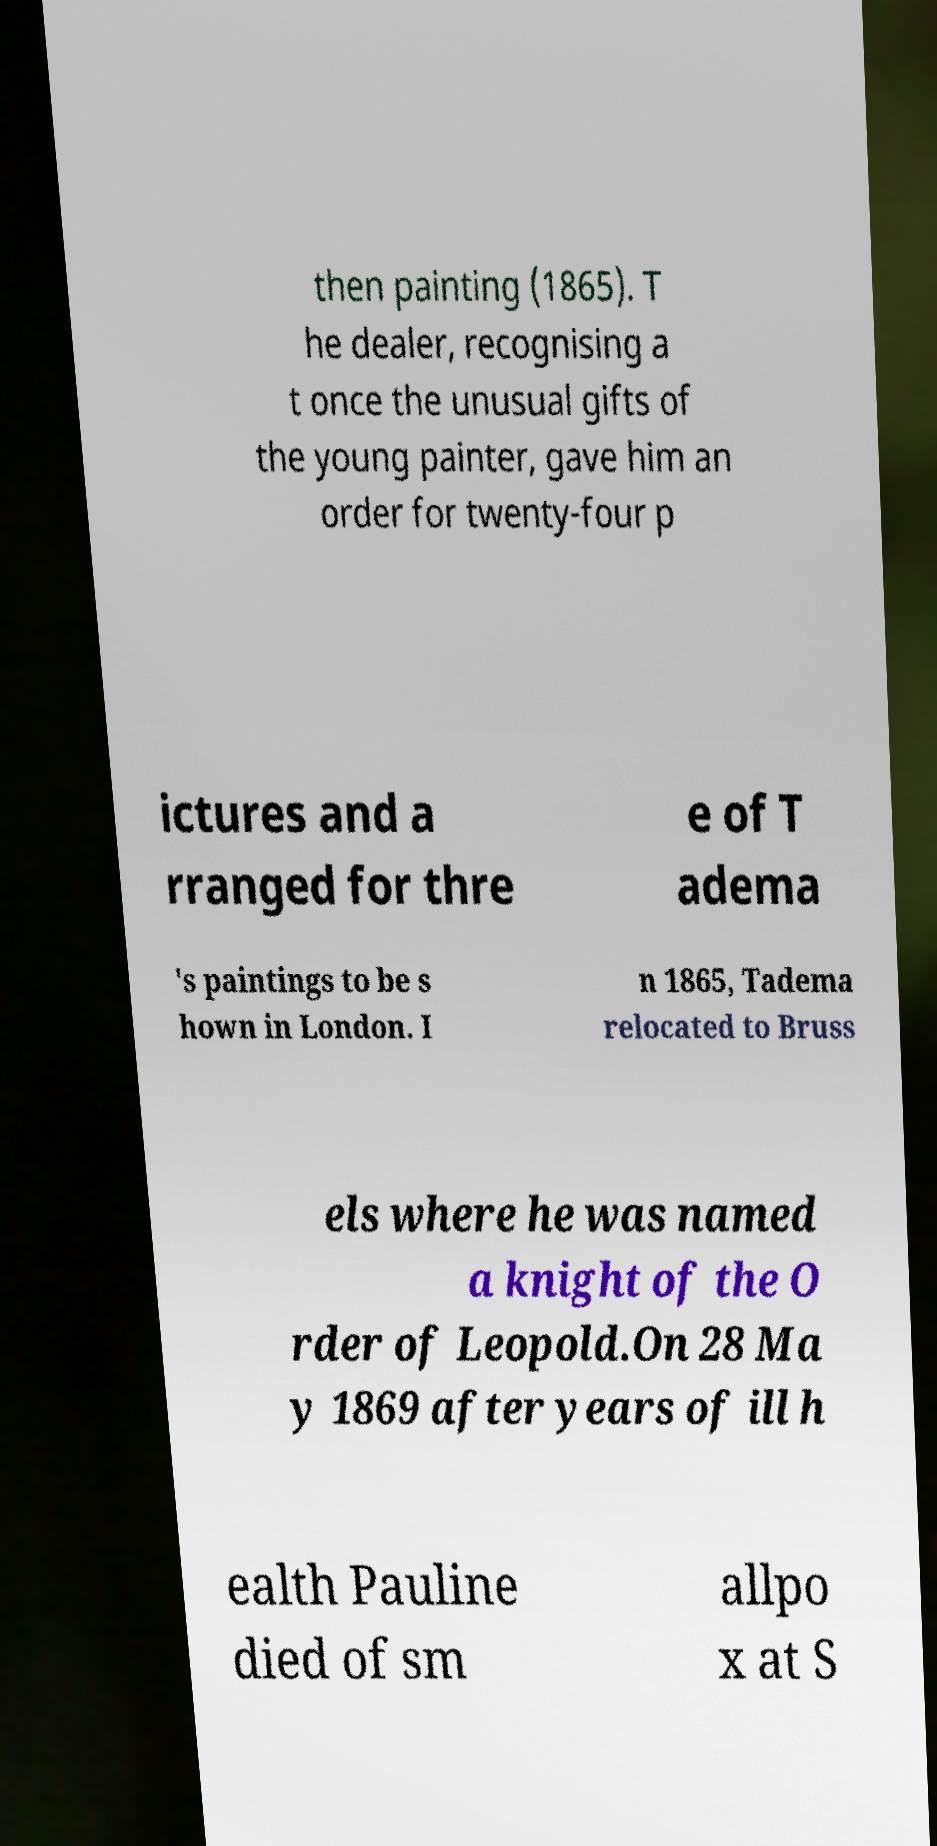For documentation purposes, I need the text within this image transcribed. Could you provide that? then painting (1865). T he dealer, recognising a t once the unusual gifts of the young painter, gave him an order for twenty-four p ictures and a rranged for thre e of T adema 's paintings to be s hown in London. I n 1865, Tadema relocated to Bruss els where he was named a knight of the O rder of Leopold.On 28 Ma y 1869 after years of ill h ealth Pauline died of sm allpo x at S 